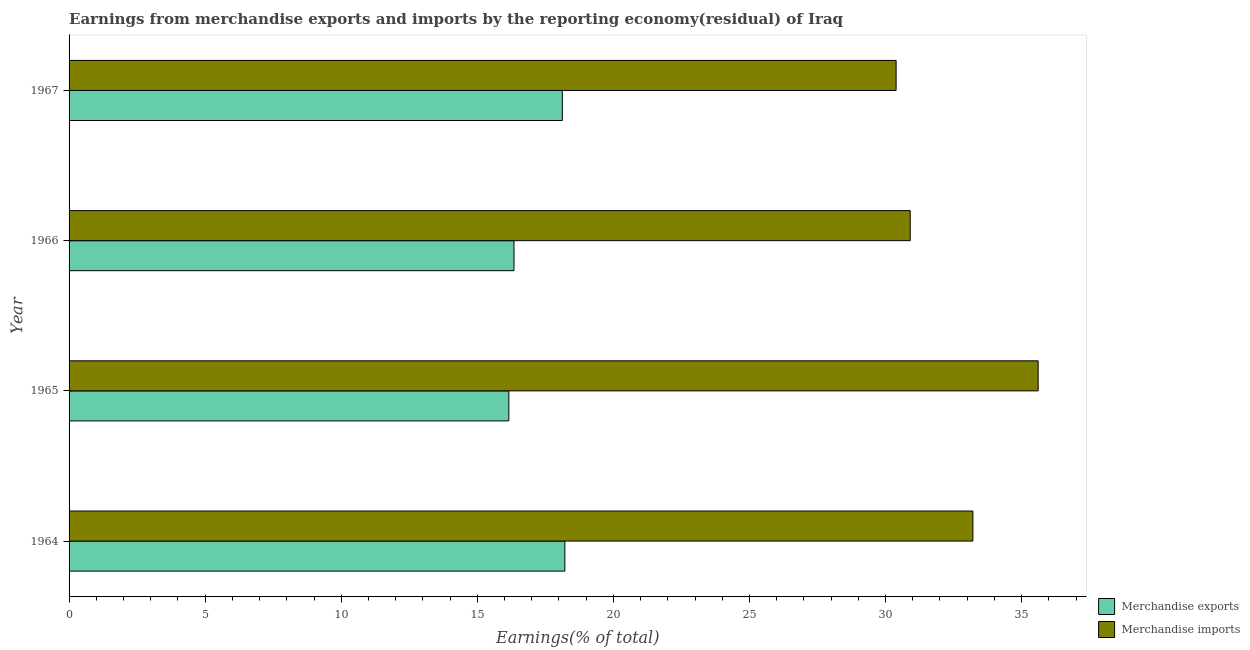Are the number of bars per tick equal to the number of legend labels?
Ensure brevity in your answer.  Yes. Are the number of bars on each tick of the Y-axis equal?
Offer a very short reply. Yes. How many bars are there on the 1st tick from the top?
Provide a succinct answer. 2. How many bars are there on the 4th tick from the bottom?
Ensure brevity in your answer.  2. What is the label of the 4th group of bars from the top?
Make the answer very short. 1964. In how many cases, is the number of bars for a given year not equal to the number of legend labels?
Provide a succinct answer. 0. What is the earnings from merchandise imports in 1964?
Make the answer very short. 33.21. Across all years, what is the maximum earnings from merchandise exports?
Provide a short and direct response. 18.22. Across all years, what is the minimum earnings from merchandise exports?
Your response must be concise. 16.16. In which year was the earnings from merchandise exports maximum?
Your response must be concise. 1964. In which year was the earnings from merchandise exports minimum?
Provide a short and direct response. 1965. What is the total earnings from merchandise imports in the graph?
Keep it short and to the point. 130.11. What is the difference between the earnings from merchandise imports in 1965 and that in 1967?
Your answer should be compact. 5.22. What is the difference between the earnings from merchandise imports in 1967 and the earnings from merchandise exports in 1965?
Provide a short and direct response. 14.23. What is the average earnings from merchandise exports per year?
Make the answer very short. 17.21. In the year 1964, what is the difference between the earnings from merchandise imports and earnings from merchandise exports?
Give a very brief answer. 14.99. In how many years, is the earnings from merchandise imports greater than 34 %?
Make the answer very short. 1. What is the ratio of the earnings from merchandise exports in 1964 to that in 1965?
Keep it short and to the point. 1.13. Is the difference between the earnings from merchandise imports in 1964 and 1966 greater than the difference between the earnings from merchandise exports in 1964 and 1966?
Your answer should be very brief. Yes. What is the difference between the highest and the second highest earnings from merchandise exports?
Provide a succinct answer. 0.09. What is the difference between the highest and the lowest earnings from merchandise exports?
Keep it short and to the point. 2.06. In how many years, is the earnings from merchandise imports greater than the average earnings from merchandise imports taken over all years?
Offer a very short reply. 2. What does the 1st bar from the top in 1967 represents?
Provide a short and direct response. Merchandise imports. Are the values on the major ticks of X-axis written in scientific E-notation?
Your response must be concise. No. Does the graph contain grids?
Ensure brevity in your answer.  No. How many legend labels are there?
Your response must be concise. 2. How are the legend labels stacked?
Offer a very short reply. Vertical. What is the title of the graph?
Your response must be concise. Earnings from merchandise exports and imports by the reporting economy(residual) of Iraq. What is the label or title of the X-axis?
Your answer should be very brief. Earnings(% of total). What is the Earnings(% of total) of Merchandise exports in 1964?
Give a very brief answer. 18.22. What is the Earnings(% of total) of Merchandise imports in 1964?
Offer a terse response. 33.21. What is the Earnings(% of total) of Merchandise exports in 1965?
Your answer should be very brief. 16.16. What is the Earnings(% of total) in Merchandise imports in 1965?
Offer a terse response. 35.61. What is the Earnings(% of total) in Merchandise exports in 1966?
Ensure brevity in your answer.  16.35. What is the Earnings(% of total) of Merchandise imports in 1966?
Your answer should be very brief. 30.91. What is the Earnings(% of total) of Merchandise exports in 1967?
Offer a very short reply. 18.12. What is the Earnings(% of total) of Merchandise imports in 1967?
Make the answer very short. 30.39. Across all years, what is the maximum Earnings(% of total) in Merchandise exports?
Your answer should be compact. 18.22. Across all years, what is the maximum Earnings(% of total) in Merchandise imports?
Your response must be concise. 35.61. Across all years, what is the minimum Earnings(% of total) in Merchandise exports?
Your answer should be compact. 16.16. Across all years, what is the minimum Earnings(% of total) in Merchandise imports?
Keep it short and to the point. 30.39. What is the total Earnings(% of total) of Merchandise exports in the graph?
Your answer should be compact. 68.85. What is the total Earnings(% of total) of Merchandise imports in the graph?
Your answer should be very brief. 130.11. What is the difference between the Earnings(% of total) in Merchandise exports in 1964 and that in 1965?
Your response must be concise. 2.06. What is the difference between the Earnings(% of total) of Merchandise imports in 1964 and that in 1965?
Keep it short and to the point. -2.4. What is the difference between the Earnings(% of total) in Merchandise exports in 1964 and that in 1966?
Offer a terse response. 1.87. What is the difference between the Earnings(% of total) in Merchandise imports in 1964 and that in 1966?
Your answer should be very brief. 2.3. What is the difference between the Earnings(% of total) of Merchandise exports in 1964 and that in 1967?
Provide a short and direct response. 0.09. What is the difference between the Earnings(% of total) in Merchandise imports in 1964 and that in 1967?
Give a very brief answer. 2.82. What is the difference between the Earnings(% of total) in Merchandise exports in 1965 and that in 1966?
Ensure brevity in your answer.  -0.19. What is the difference between the Earnings(% of total) in Merchandise imports in 1965 and that in 1966?
Ensure brevity in your answer.  4.7. What is the difference between the Earnings(% of total) in Merchandise exports in 1965 and that in 1967?
Your answer should be compact. -1.96. What is the difference between the Earnings(% of total) in Merchandise imports in 1965 and that in 1967?
Provide a short and direct response. 5.22. What is the difference between the Earnings(% of total) of Merchandise exports in 1966 and that in 1967?
Offer a terse response. -1.78. What is the difference between the Earnings(% of total) of Merchandise imports in 1966 and that in 1967?
Provide a short and direct response. 0.52. What is the difference between the Earnings(% of total) of Merchandise exports in 1964 and the Earnings(% of total) of Merchandise imports in 1965?
Your answer should be very brief. -17.39. What is the difference between the Earnings(% of total) of Merchandise exports in 1964 and the Earnings(% of total) of Merchandise imports in 1966?
Ensure brevity in your answer.  -12.69. What is the difference between the Earnings(% of total) in Merchandise exports in 1964 and the Earnings(% of total) in Merchandise imports in 1967?
Your response must be concise. -12.17. What is the difference between the Earnings(% of total) of Merchandise exports in 1965 and the Earnings(% of total) of Merchandise imports in 1966?
Ensure brevity in your answer.  -14.75. What is the difference between the Earnings(% of total) in Merchandise exports in 1965 and the Earnings(% of total) in Merchandise imports in 1967?
Your answer should be very brief. -14.23. What is the difference between the Earnings(% of total) of Merchandise exports in 1966 and the Earnings(% of total) of Merchandise imports in 1967?
Your answer should be compact. -14.04. What is the average Earnings(% of total) of Merchandise exports per year?
Offer a terse response. 17.21. What is the average Earnings(% of total) of Merchandise imports per year?
Offer a terse response. 32.53. In the year 1964, what is the difference between the Earnings(% of total) in Merchandise exports and Earnings(% of total) in Merchandise imports?
Your answer should be compact. -14.99. In the year 1965, what is the difference between the Earnings(% of total) of Merchandise exports and Earnings(% of total) of Merchandise imports?
Offer a terse response. -19.45. In the year 1966, what is the difference between the Earnings(% of total) of Merchandise exports and Earnings(% of total) of Merchandise imports?
Your answer should be compact. -14.56. In the year 1967, what is the difference between the Earnings(% of total) of Merchandise exports and Earnings(% of total) of Merchandise imports?
Your response must be concise. -12.26. What is the ratio of the Earnings(% of total) in Merchandise exports in 1964 to that in 1965?
Give a very brief answer. 1.13. What is the ratio of the Earnings(% of total) of Merchandise imports in 1964 to that in 1965?
Provide a short and direct response. 0.93. What is the ratio of the Earnings(% of total) of Merchandise exports in 1964 to that in 1966?
Make the answer very short. 1.11. What is the ratio of the Earnings(% of total) of Merchandise imports in 1964 to that in 1966?
Keep it short and to the point. 1.07. What is the ratio of the Earnings(% of total) of Merchandise exports in 1964 to that in 1967?
Offer a very short reply. 1.01. What is the ratio of the Earnings(% of total) in Merchandise imports in 1964 to that in 1967?
Offer a terse response. 1.09. What is the ratio of the Earnings(% of total) in Merchandise exports in 1965 to that in 1966?
Ensure brevity in your answer.  0.99. What is the ratio of the Earnings(% of total) in Merchandise imports in 1965 to that in 1966?
Your answer should be very brief. 1.15. What is the ratio of the Earnings(% of total) in Merchandise exports in 1965 to that in 1967?
Your response must be concise. 0.89. What is the ratio of the Earnings(% of total) of Merchandise imports in 1965 to that in 1967?
Provide a succinct answer. 1.17. What is the ratio of the Earnings(% of total) of Merchandise exports in 1966 to that in 1967?
Give a very brief answer. 0.9. What is the difference between the highest and the second highest Earnings(% of total) in Merchandise exports?
Keep it short and to the point. 0.09. What is the difference between the highest and the second highest Earnings(% of total) in Merchandise imports?
Provide a succinct answer. 2.4. What is the difference between the highest and the lowest Earnings(% of total) of Merchandise exports?
Make the answer very short. 2.06. What is the difference between the highest and the lowest Earnings(% of total) of Merchandise imports?
Offer a terse response. 5.22. 